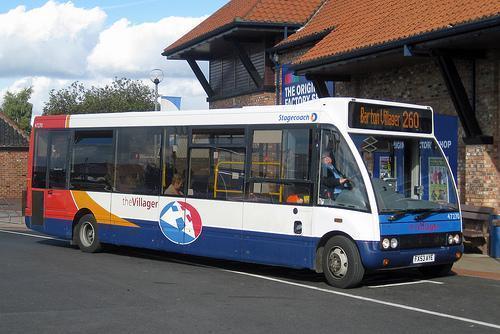How many buses are in this picture?
Give a very brief answer. 1. How many tires can you see in the picture?
Give a very brief answer. 2. 